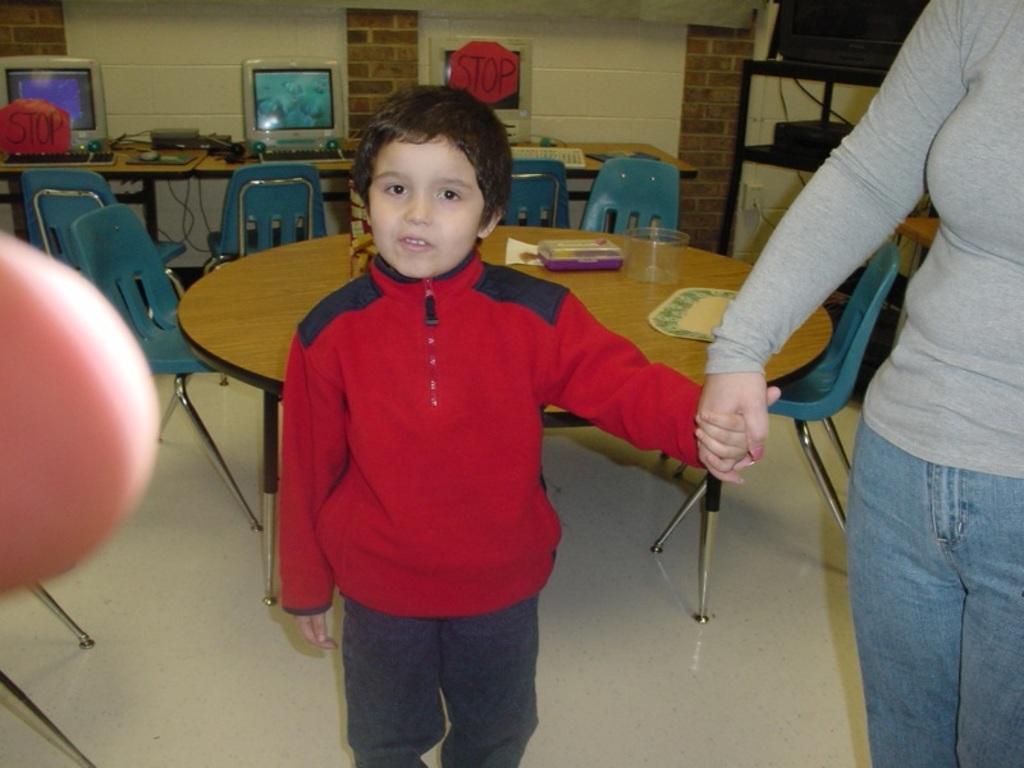Please provide a concise description of this image. In this image in the center there is one boy who is standing. Beside that boy there is one woman who is standing, on the background there is a table and some chairs and on the table there is one box and one cloth is there and on the top there is a wall and on the left side there is a table. On that table there are computers and keyboards are there. 